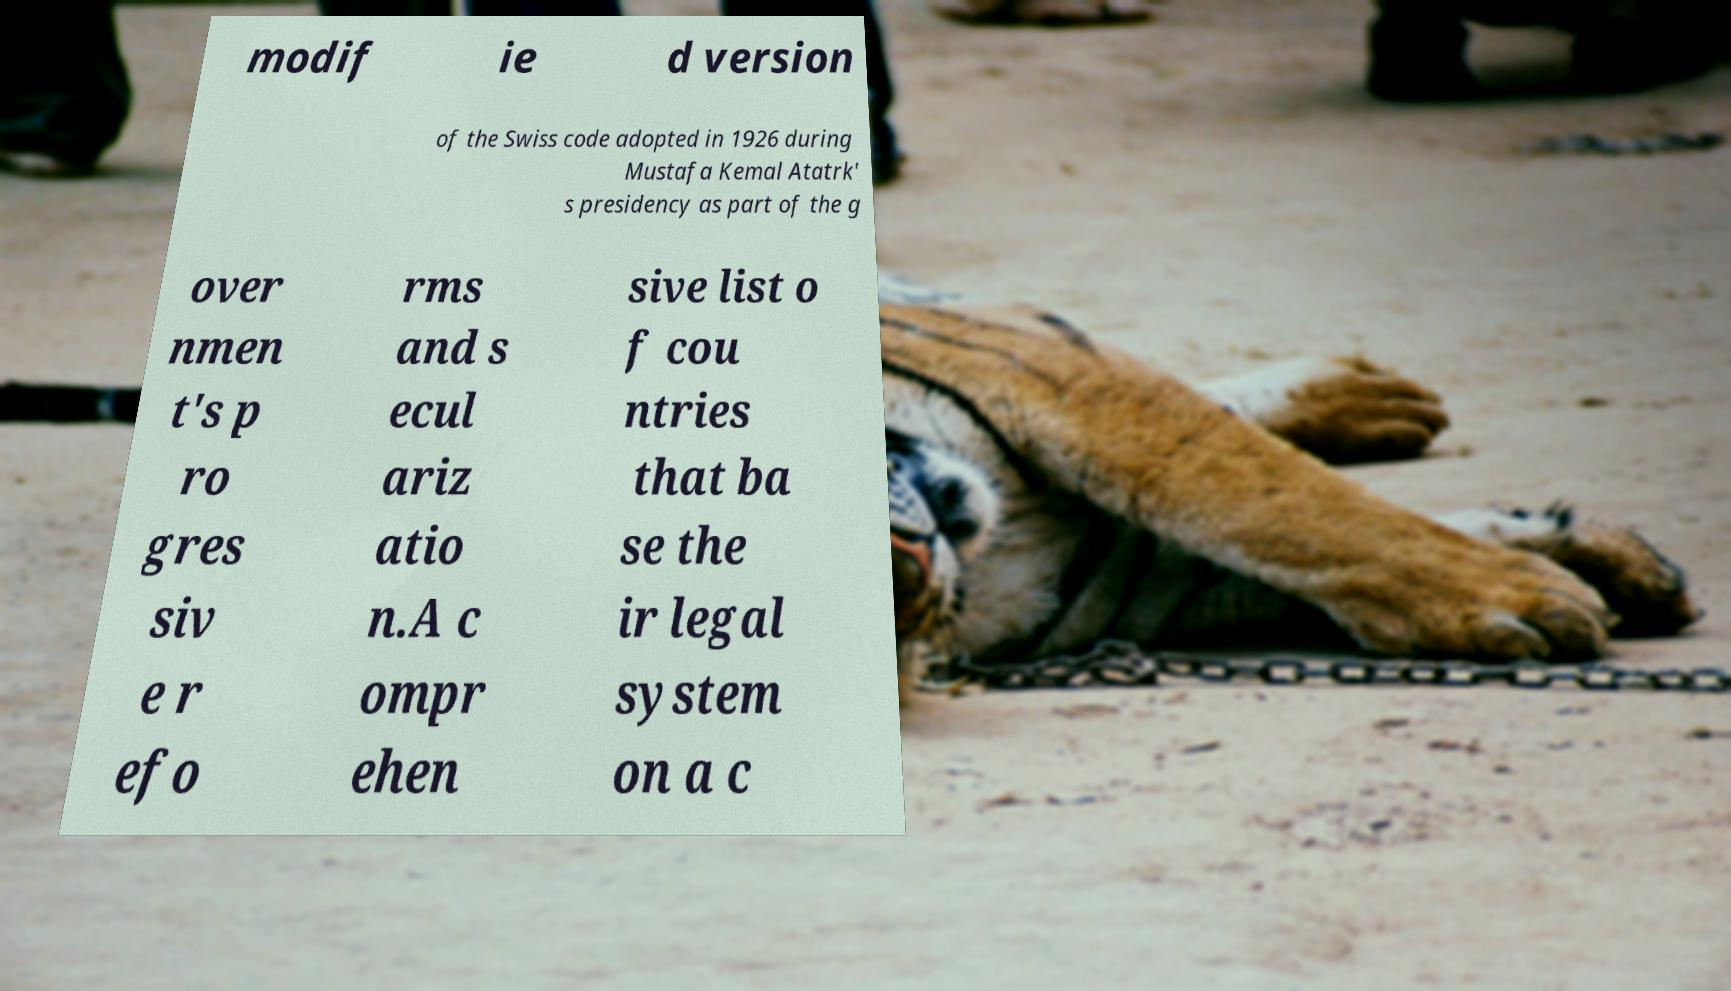Can you accurately transcribe the text from the provided image for me? modif ie d version of the Swiss code adopted in 1926 during Mustafa Kemal Atatrk' s presidency as part of the g over nmen t's p ro gres siv e r efo rms and s ecul ariz atio n.A c ompr ehen sive list o f cou ntries that ba se the ir legal system on a c 